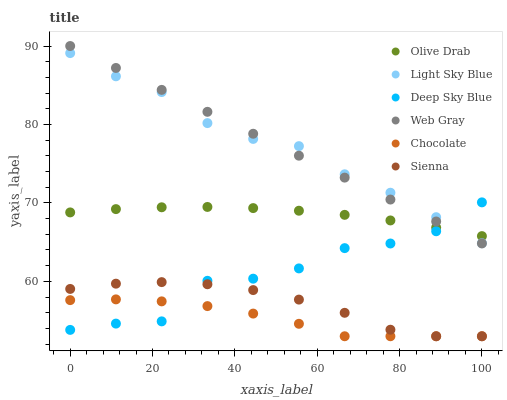Does Chocolate have the minimum area under the curve?
Answer yes or no. Yes. Does Web Gray have the maximum area under the curve?
Answer yes or no. Yes. Does Sienna have the minimum area under the curve?
Answer yes or no. No. Does Sienna have the maximum area under the curve?
Answer yes or no. No. Is Web Gray the smoothest?
Answer yes or no. Yes. Is Deep Sky Blue the roughest?
Answer yes or no. Yes. Is Chocolate the smoothest?
Answer yes or no. No. Is Chocolate the roughest?
Answer yes or no. No. Does Chocolate have the lowest value?
Answer yes or no. Yes. Does Light Sky Blue have the lowest value?
Answer yes or no. No. Does Web Gray have the highest value?
Answer yes or no. Yes. Does Sienna have the highest value?
Answer yes or no. No. Is Chocolate less than Olive Drab?
Answer yes or no. Yes. Is Light Sky Blue greater than Chocolate?
Answer yes or no. Yes. Does Web Gray intersect Olive Drab?
Answer yes or no. Yes. Is Web Gray less than Olive Drab?
Answer yes or no. No. Is Web Gray greater than Olive Drab?
Answer yes or no. No. Does Chocolate intersect Olive Drab?
Answer yes or no. No. 